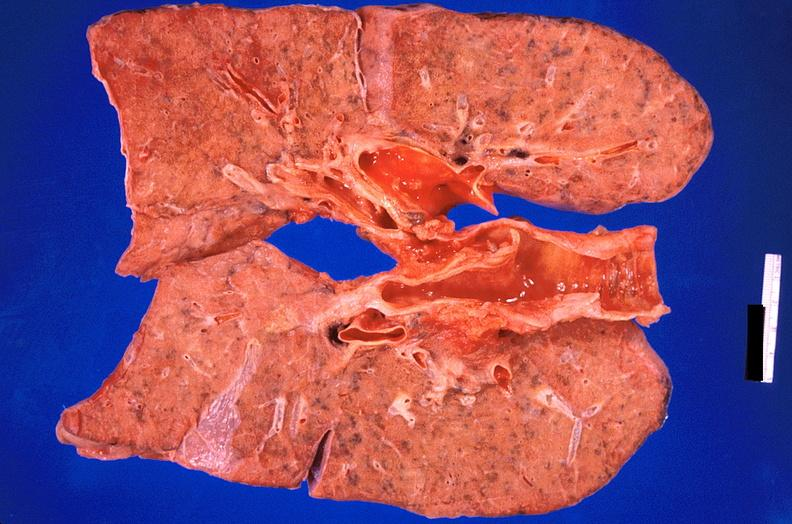does this image show lung, pulmonary fibrosis and atherosclerosis of pulmonary artery?
Answer the question using a single word or phrase. Yes 